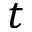<formula> <loc_0><loc_0><loc_500><loc_500>t</formula> 